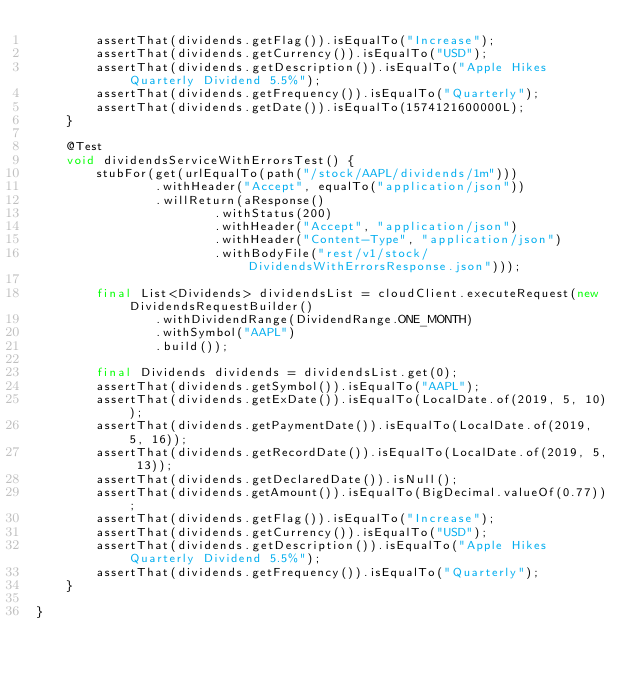<code> <loc_0><loc_0><loc_500><loc_500><_Java_>        assertThat(dividends.getFlag()).isEqualTo("Increase");
        assertThat(dividends.getCurrency()).isEqualTo("USD");
        assertThat(dividends.getDescription()).isEqualTo("Apple Hikes Quarterly Dividend 5.5%");
        assertThat(dividends.getFrequency()).isEqualTo("Quarterly");
        assertThat(dividends.getDate()).isEqualTo(1574121600000L);
    }

    @Test
    void dividendsServiceWithErrorsTest() {
        stubFor(get(urlEqualTo(path("/stock/AAPL/dividends/1m")))
                .withHeader("Accept", equalTo("application/json"))
                .willReturn(aResponse()
                        .withStatus(200)
                        .withHeader("Accept", "application/json")
                        .withHeader("Content-Type", "application/json")
                        .withBodyFile("rest/v1/stock/DividendsWithErrorsResponse.json")));

        final List<Dividends> dividendsList = cloudClient.executeRequest(new DividendsRequestBuilder()
                .withDividendRange(DividendRange.ONE_MONTH)
                .withSymbol("AAPL")
                .build());

        final Dividends dividends = dividendsList.get(0);
        assertThat(dividends.getSymbol()).isEqualTo("AAPL");
        assertThat(dividends.getExDate()).isEqualTo(LocalDate.of(2019, 5, 10));
        assertThat(dividends.getPaymentDate()).isEqualTo(LocalDate.of(2019, 5, 16));
        assertThat(dividends.getRecordDate()).isEqualTo(LocalDate.of(2019, 5, 13));
        assertThat(dividends.getDeclaredDate()).isNull();
        assertThat(dividends.getAmount()).isEqualTo(BigDecimal.valueOf(0.77));
        assertThat(dividends.getFlag()).isEqualTo("Increase");
        assertThat(dividends.getCurrency()).isEqualTo("USD");
        assertThat(dividends.getDescription()).isEqualTo("Apple Hikes Quarterly Dividend 5.5%");
        assertThat(dividends.getFrequency()).isEqualTo("Quarterly");
    }

}
</code> 